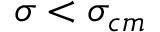Convert formula to latex. <formula><loc_0><loc_0><loc_500><loc_500>\sigma < \sigma _ { c m }</formula> 